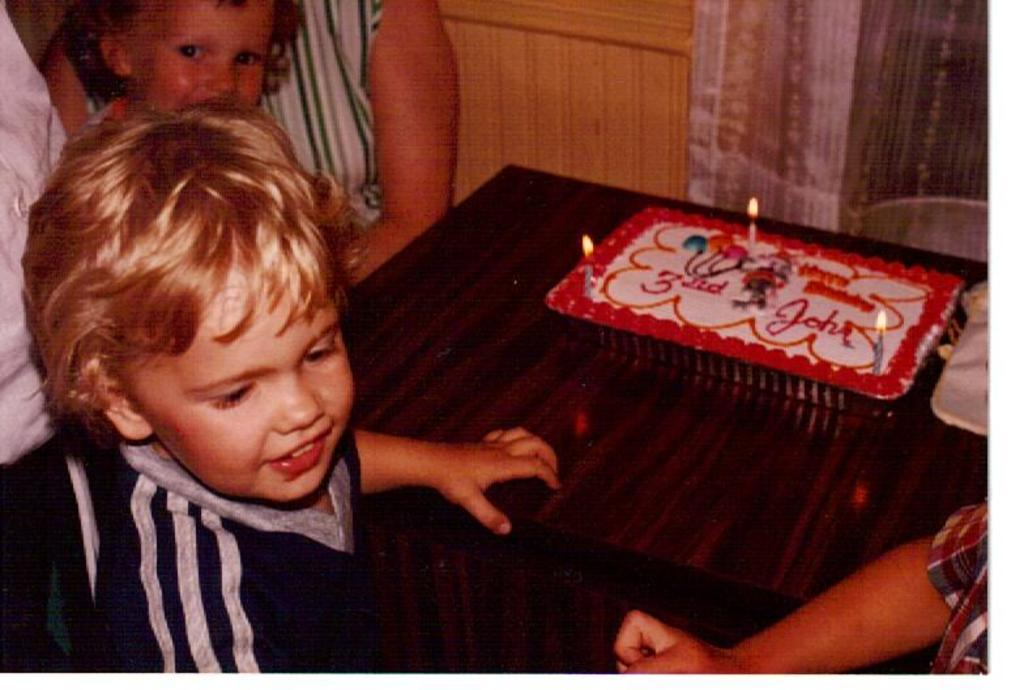What is the main subject of the image? There is a kid in the image. What else can be seen in the image besides the kid? There is a table in the image. What is on the table? There is a cake on the table. Are there any decorations on the cake? Yes, there are candles on the cake. What type of game is being played on the bridge in the garden? There is no game, bridge, or garden present in the image. The image only features a kid, a table, a cake, and candles. 